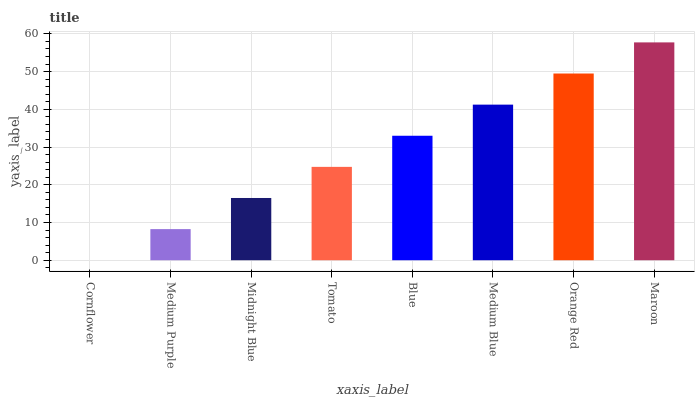Is Cornflower the minimum?
Answer yes or no. Yes. Is Maroon the maximum?
Answer yes or no. Yes. Is Medium Purple the minimum?
Answer yes or no. No. Is Medium Purple the maximum?
Answer yes or no. No. Is Medium Purple greater than Cornflower?
Answer yes or no. Yes. Is Cornflower less than Medium Purple?
Answer yes or no. Yes. Is Cornflower greater than Medium Purple?
Answer yes or no. No. Is Medium Purple less than Cornflower?
Answer yes or no. No. Is Blue the high median?
Answer yes or no. Yes. Is Tomato the low median?
Answer yes or no. Yes. Is Cornflower the high median?
Answer yes or no. No. Is Blue the low median?
Answer yes or no. No. 